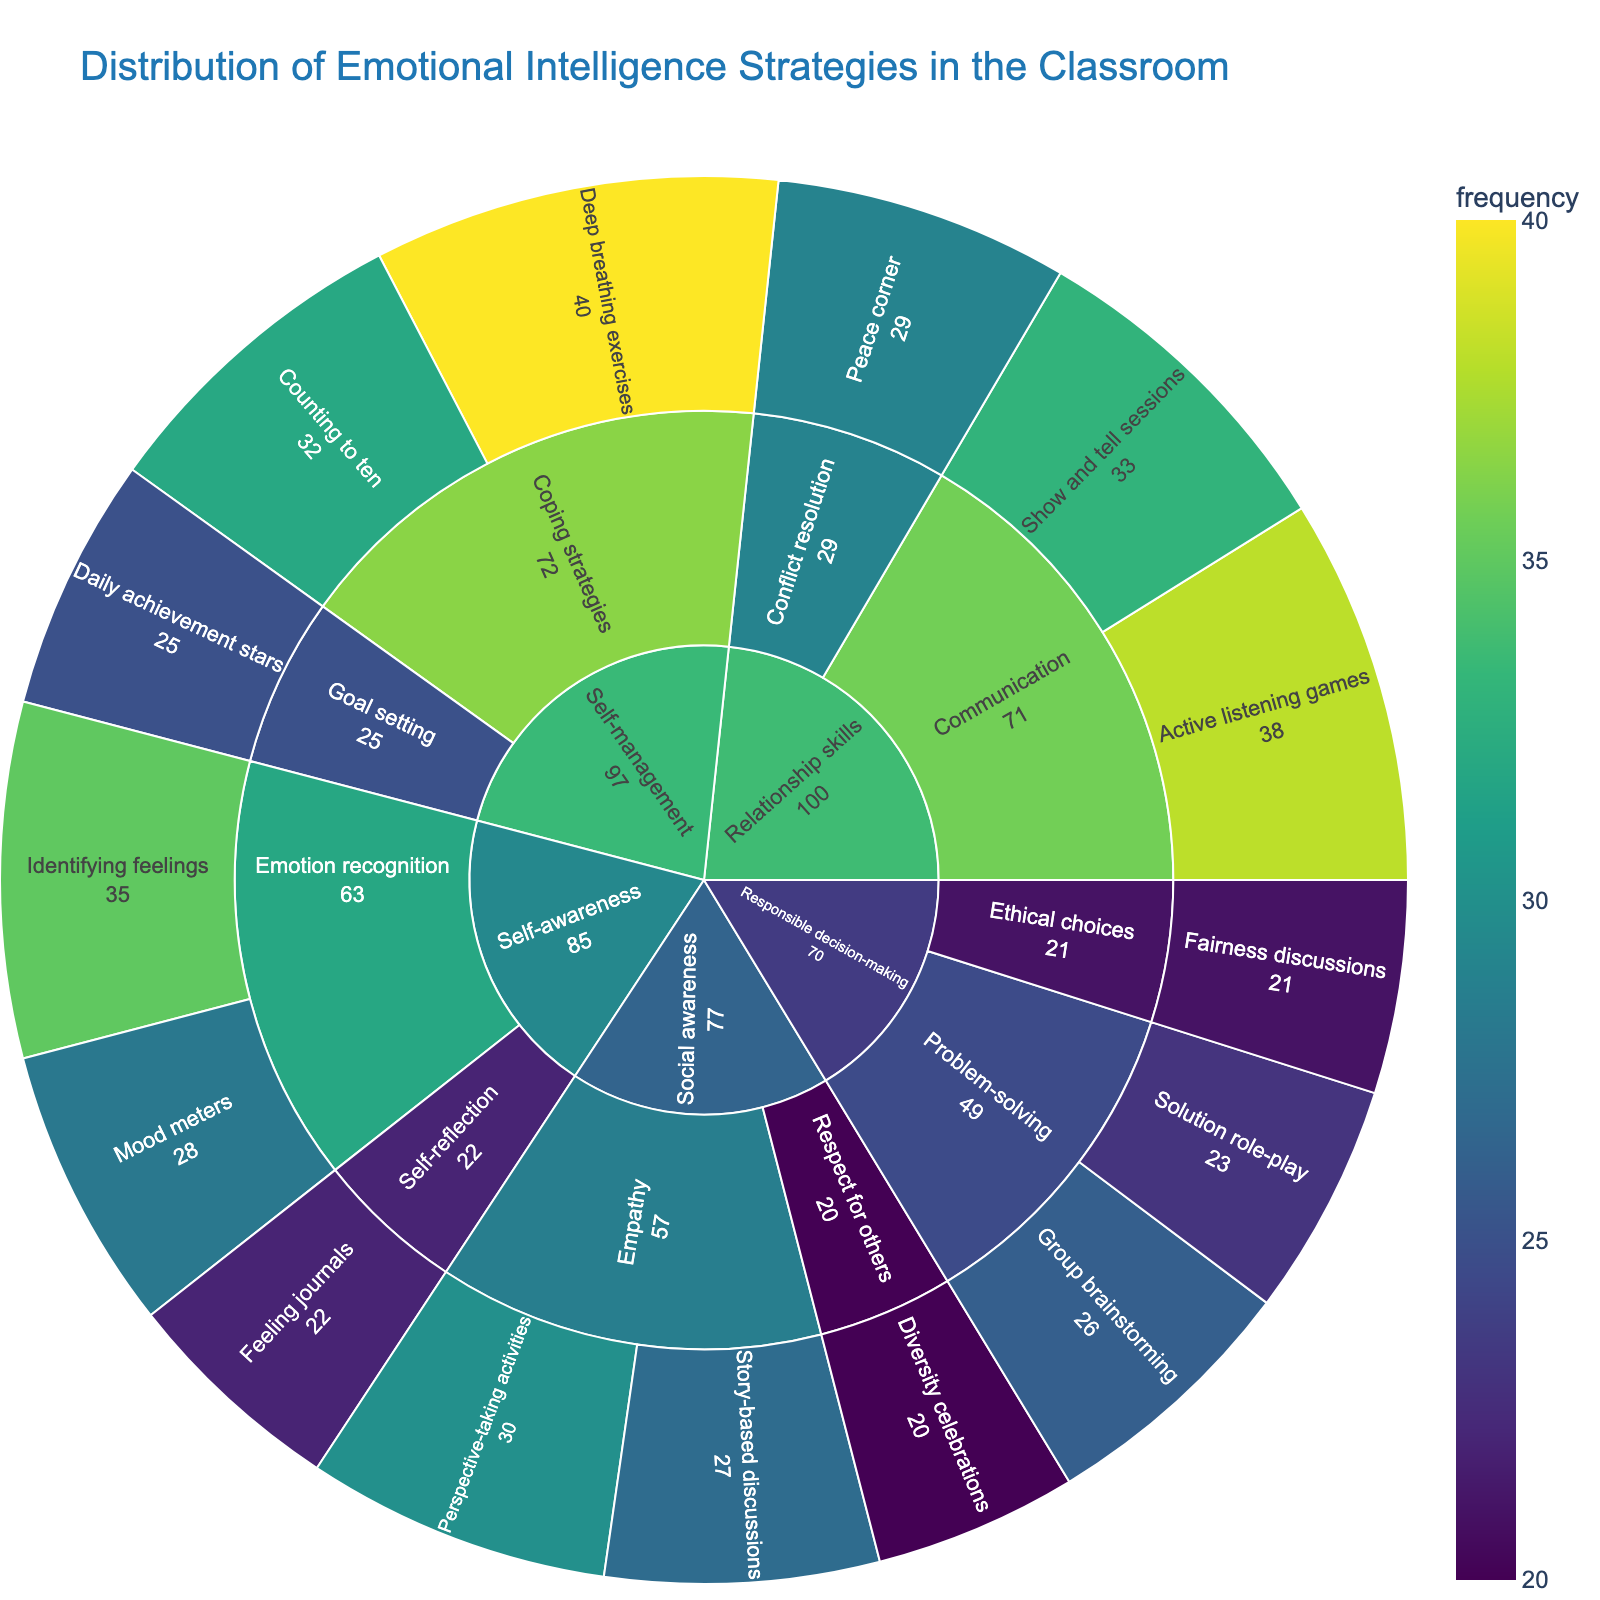what is the title of the figure? The title is usually displayed at the top of the plot. In this case, the title would be found at the top center.
Answer: Distribution of Emotional Intelligence Strategies in the Classroom what strategy under 'self-awareness' has the highest frequency? Look at the segment under 'Self-awareness' and identify the strategy with the largest area, which represents the highest frequency.
Answer: Identifying feelings how many total strategies are there under 'self-management'? Count the number of distinct segments under the 'Self-management' category.
Answer: 3 compare the frequency of 'deep breathing exercises' and 'daily achievement stars'. Which one is higher? Locate both strategies under 'Self-management' and compare their frequency values. 'Deep breathing exercises' has a frequency of 40, while 'daily achievement stars' has a frequency of 25.
Answer: Deep breathing exercises what is the combined frequency of all 'problem-solving' strategies? Find the frequencies of 'Group brainstorming' and 'Solution role-play' under 'Responsible decision-making', then add them together (26 + 23).
Answer: 49 which category has the least frequent strategy, and what is that strategy? Look for the smallest segment across all categories and note its category and strategy.
Answer: Social awareness, Diversity celebrations calculate the average frequency of strategies under 'empathy'. Identify the strategies under 'Social awareness -> Empathy' (Perspective-taking activities and Story-based discussions) and compute their average (30 + 27)/2.
Answer: 28.5 compare the number of subcategories under 'relationship skills' and 'responsible decision-making'. Which one has more? Count the subcategories under both 'Relationship skills' and 'Responsible decision-making'.
Answer: Relationship skills what is the frequency difference between 'active listening games' and 'show and tell sessions'? Subtract the frequency of 'Show and tell sessions' from 'Active listening games' (38 - 33).
Answer: 5 what subcategory has 'fairness discussions' in it, and what category is it under? Trace 'Fairness discussions' from the outermost ring inwards to find its subcategory and category.
Answer: Ethical choices, Responsible decision-making 